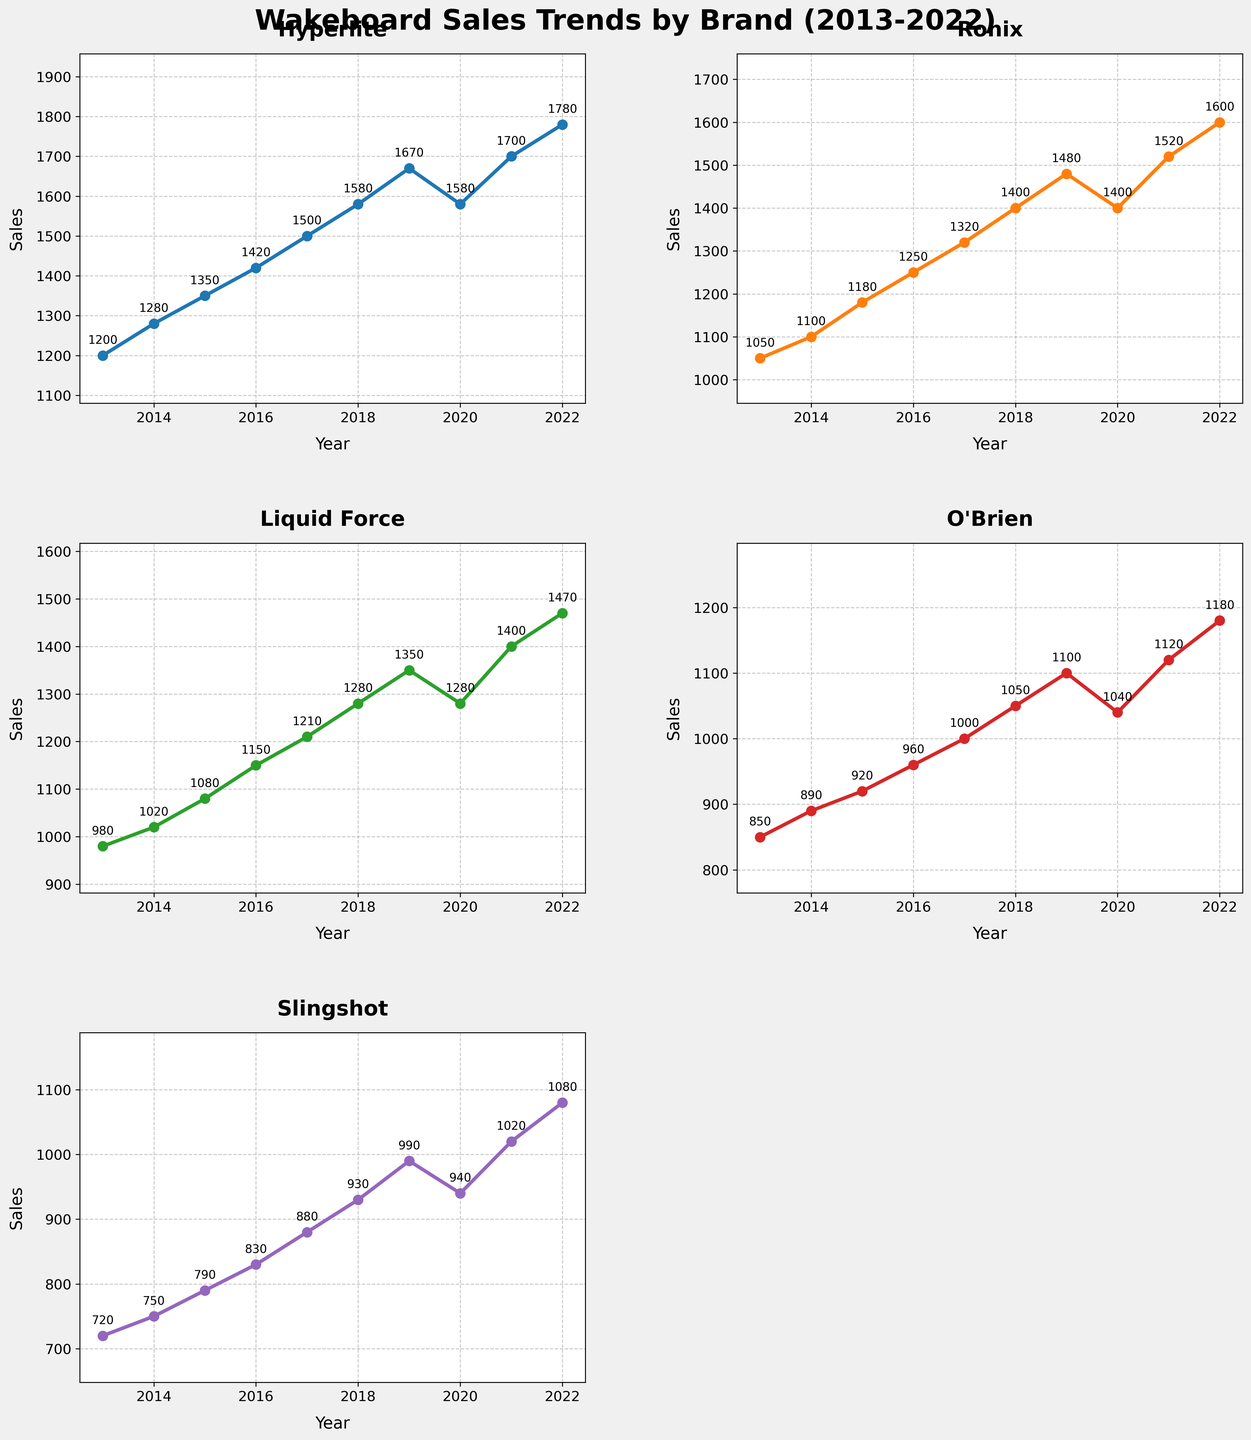How many subplots are there in the figure? The figure consists of a grid with 3 rows and 2 columns. However, one of the subplots is removed. So, there are 5 subplots.
Answer: 5 Which brand experienced a dip in sales in 2020 compared to 2019? By observing the plotted lines, we notice that the sales for Hyperlite and Ronix dip in 2020 compared to 2019.
Answer: Hyperlite, Ronix What was the highest sales figure for Hyperlite over the decade? From the annotated plot for Hyperlite, the highest value in the given period is 1780 in 2022.
Answer: 1780 Which brand saw the most consistent growth over the years? By comparing the slopes of the lines for each brand, Liquid Force and O'Brien show a steady increase without any dips. All their annual increases look consistent, but Liquid Force has the same sales in 2018 as in 2020 which is not the case for O'Brien. So, O'Brien has the most consistent growth.
Answer: O'Brien What was the total sales for Ronix between 2014 and 2016? Summing up the sales for Ronix for the years listed: 1100 (2014), 1180 (2015), and 1250 (2016): 1100 + 1180 + 1250 = 3530.
Answer: 3530 Which two brands had overlapping sales values in any year within the dataset? By looking at the subplots, in 2020, both Liquid Force and Hyperlite have overlapping sales values of 1580.
Answer: Liquid Force, Hyperlite What year did Slingshot have its lowest sales? Reviewing the data points for Slingshot in the subplot, the lowest value is in 2013 with 720.
Answer: 2013 By how much did the sales of O'Brien increase from 2013 to 2022? The sales for O'Brien in 2013 is 850 and in 2022 is 1180. The increase is 1180 - 850 = 330.
Answer: 330 Which brand had the highest increase in sales in 2022 compared to 2021? By looking at the differences between 2021 and 2022 sales for each brand: Hyperlite (80), Ronix (80), Liquid Force (70), O'Brien (60), and Slingshot (60). The highest increase is for Hyperlite and Ronix with an increase of 80.
Answer: Hyperlite, Ronix 